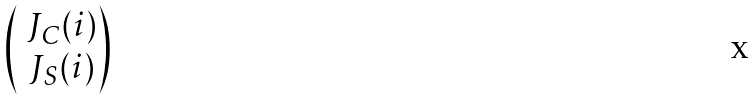<formula> <loc_0><loc_0><loc_500><loc_500>\begin{pmatrix} \ J _ { C } ( i ) \\ \ J _ { S } ( i ) \end{pmatrix}</formula> 